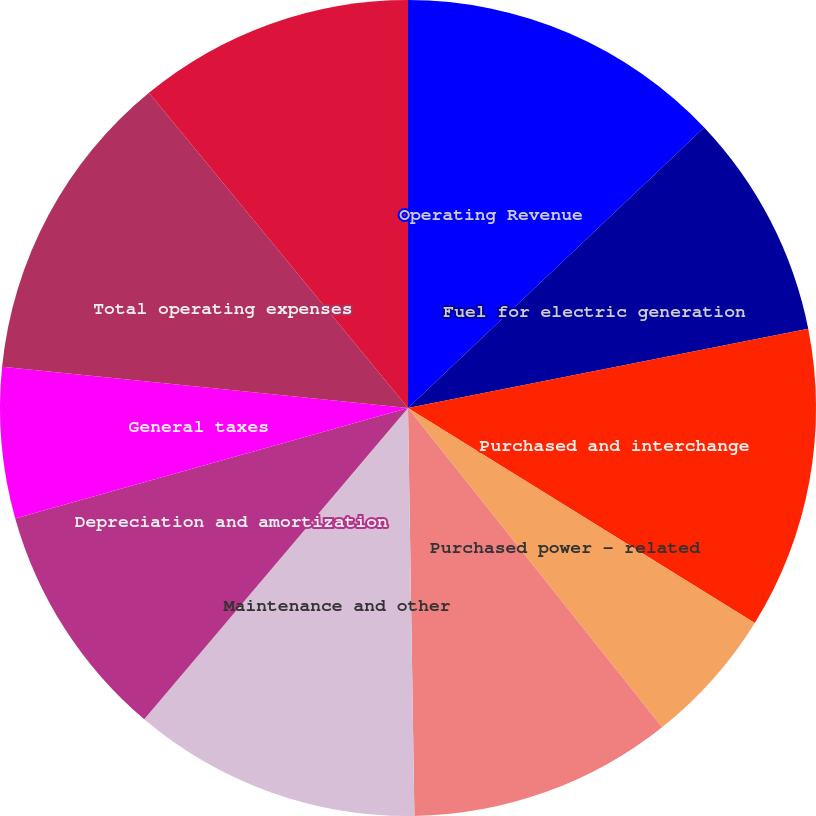Convert chart to OTSL. <chart><loc_0><loc_0><loc_500><loc_500><pie_chart><fcel>Operating Revenue<fcel>Fuel for electric generation<fcel>Purchased and interchange<fcel>Purchased power - related<fcel>Cost of gas sold<fcel>Maintenance and other<fcel>Depreciation and amortization<fcel>General taxes<fcel>Total operating expenses<fcel>Operating Income<nl><fcel>12.93%<fcel>8.96%<fcel>11.94%<fcel>5.47%<fcel>10.45%<fcel>11.44%<fcel>9.45%<fcel>5.97%<fcel>12.44%<fcel>10.95%<nl></chart> 